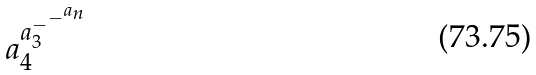<formula> <loc_0><loc_0><loc_500><loc_500>a _ { 4 } ^ { a _ { 3 } ^ { - ^ { - ^ { a _ { n } } } } }</formula> 